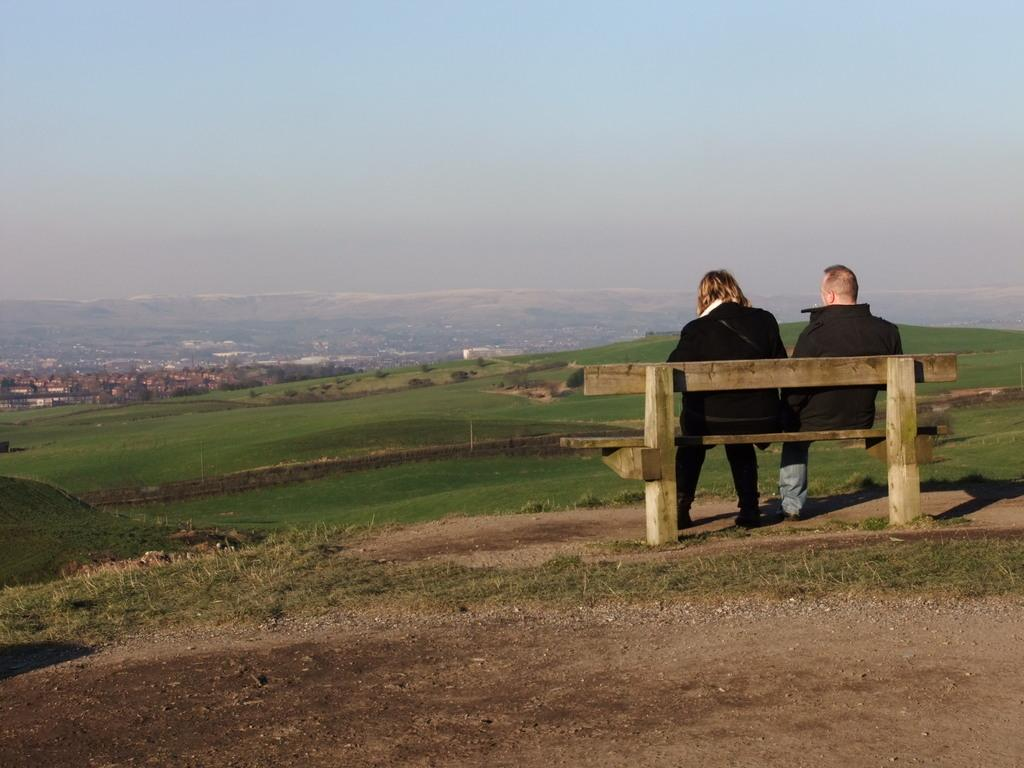How many people are sitting on the bench in the image? There are two persons sitting on a bench in the image. What can be seen in the background of the image? There are buildings and the sky visible in the background of the image. What type of nail is being used by the person sitting on the bench? There is no nail visible in the image, and it is not clear what activity the persons on the bench might be engaged in. 